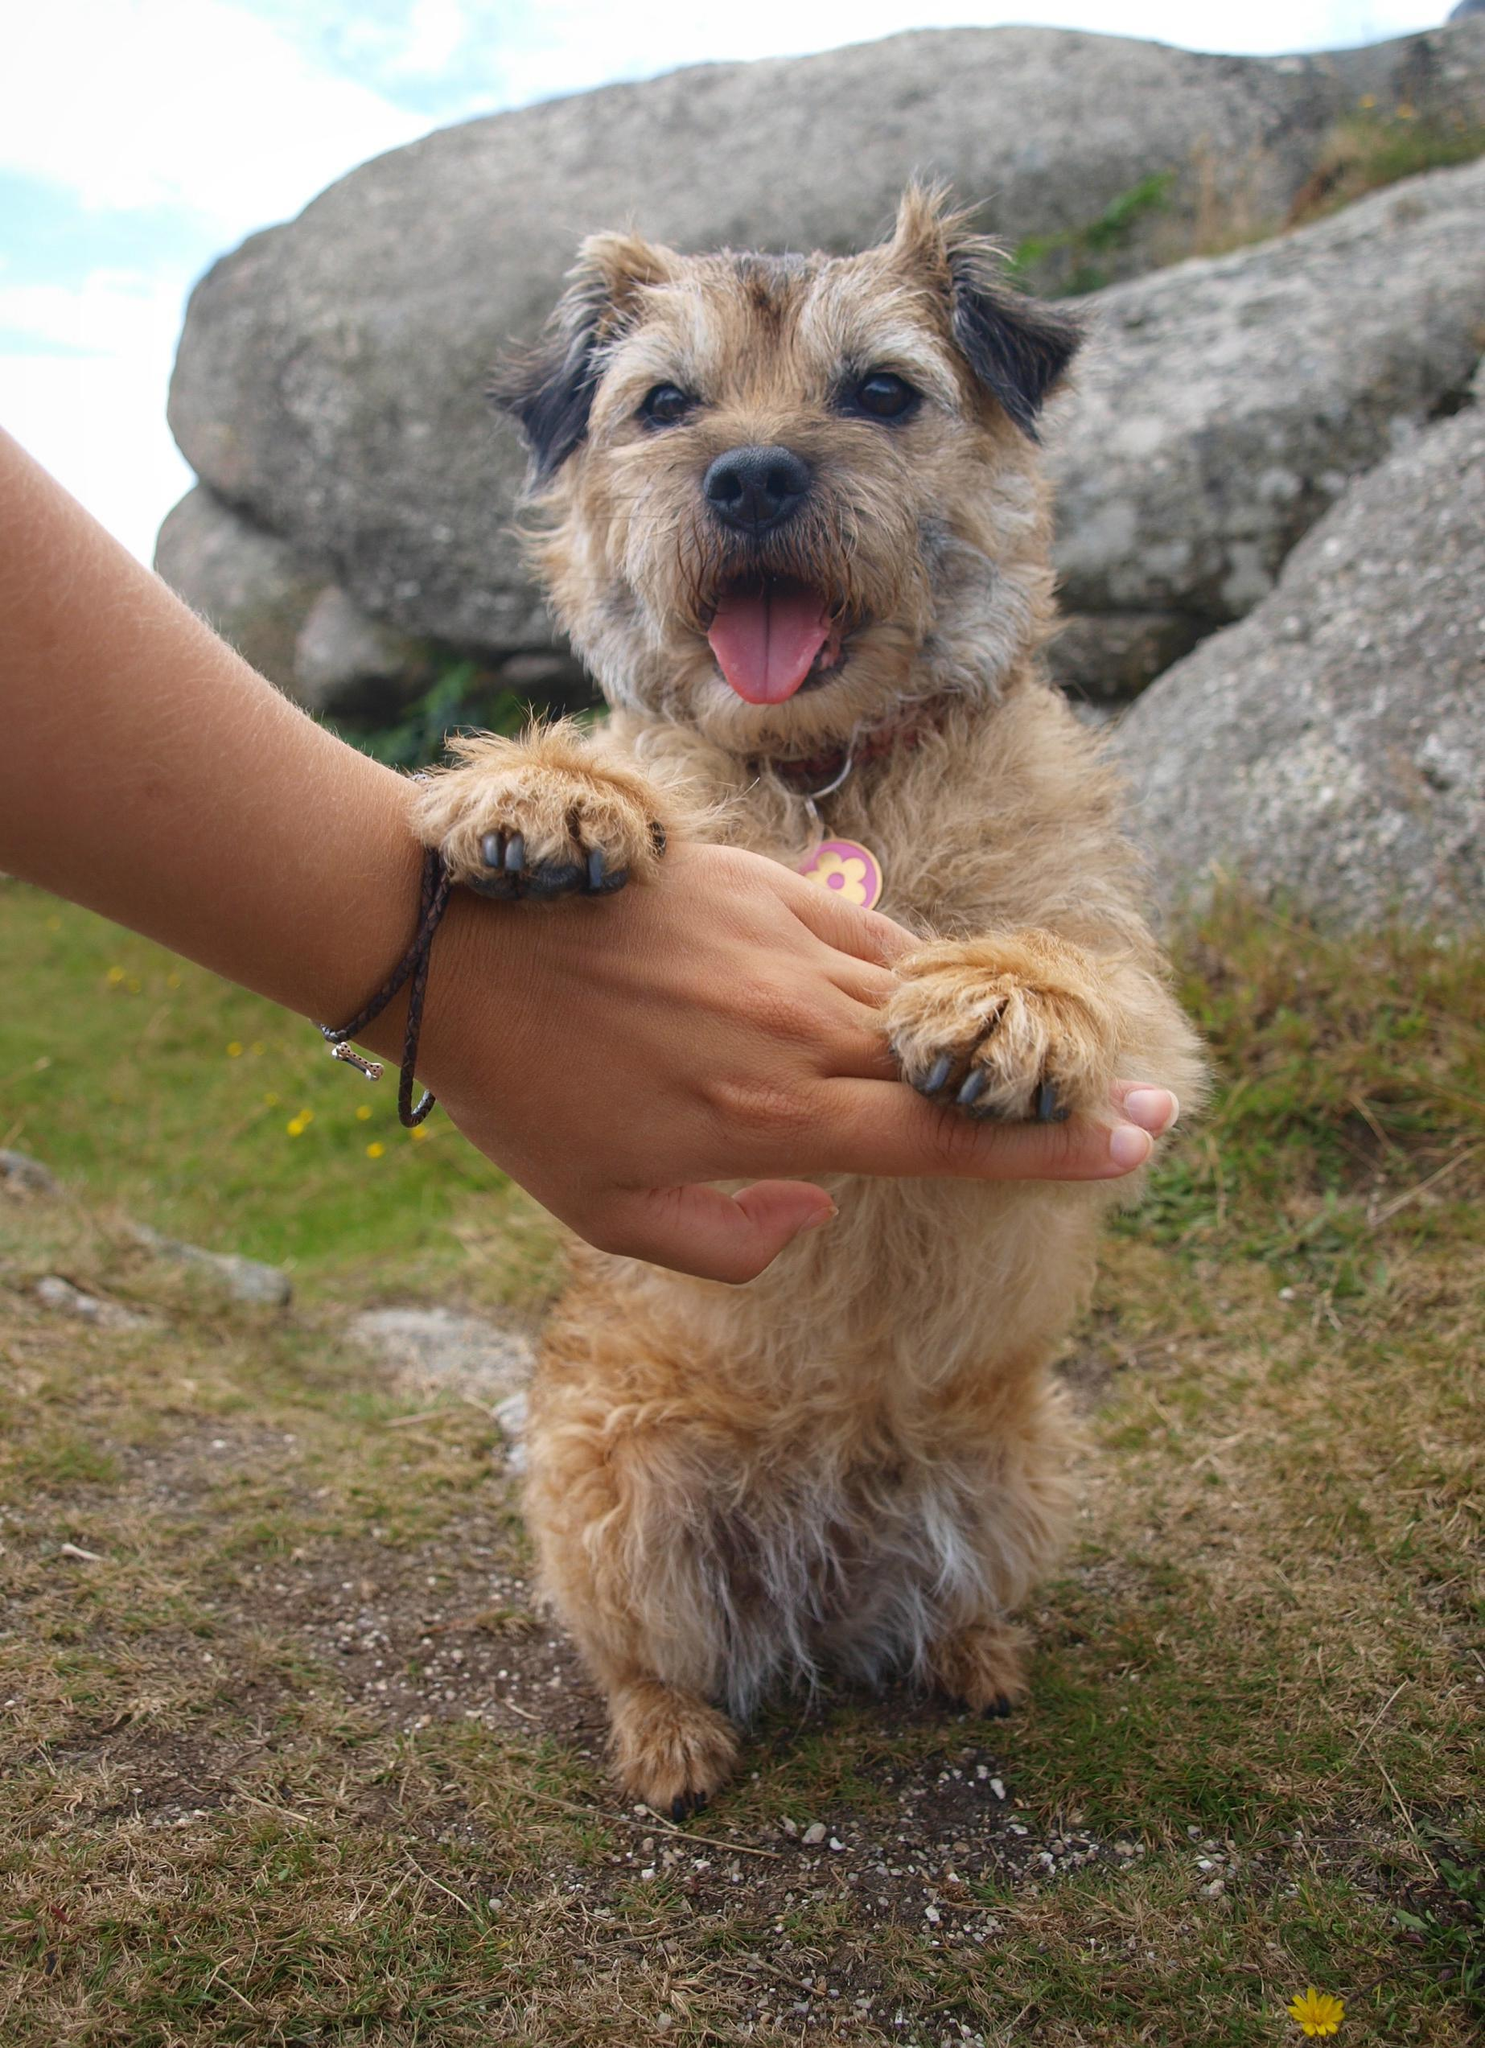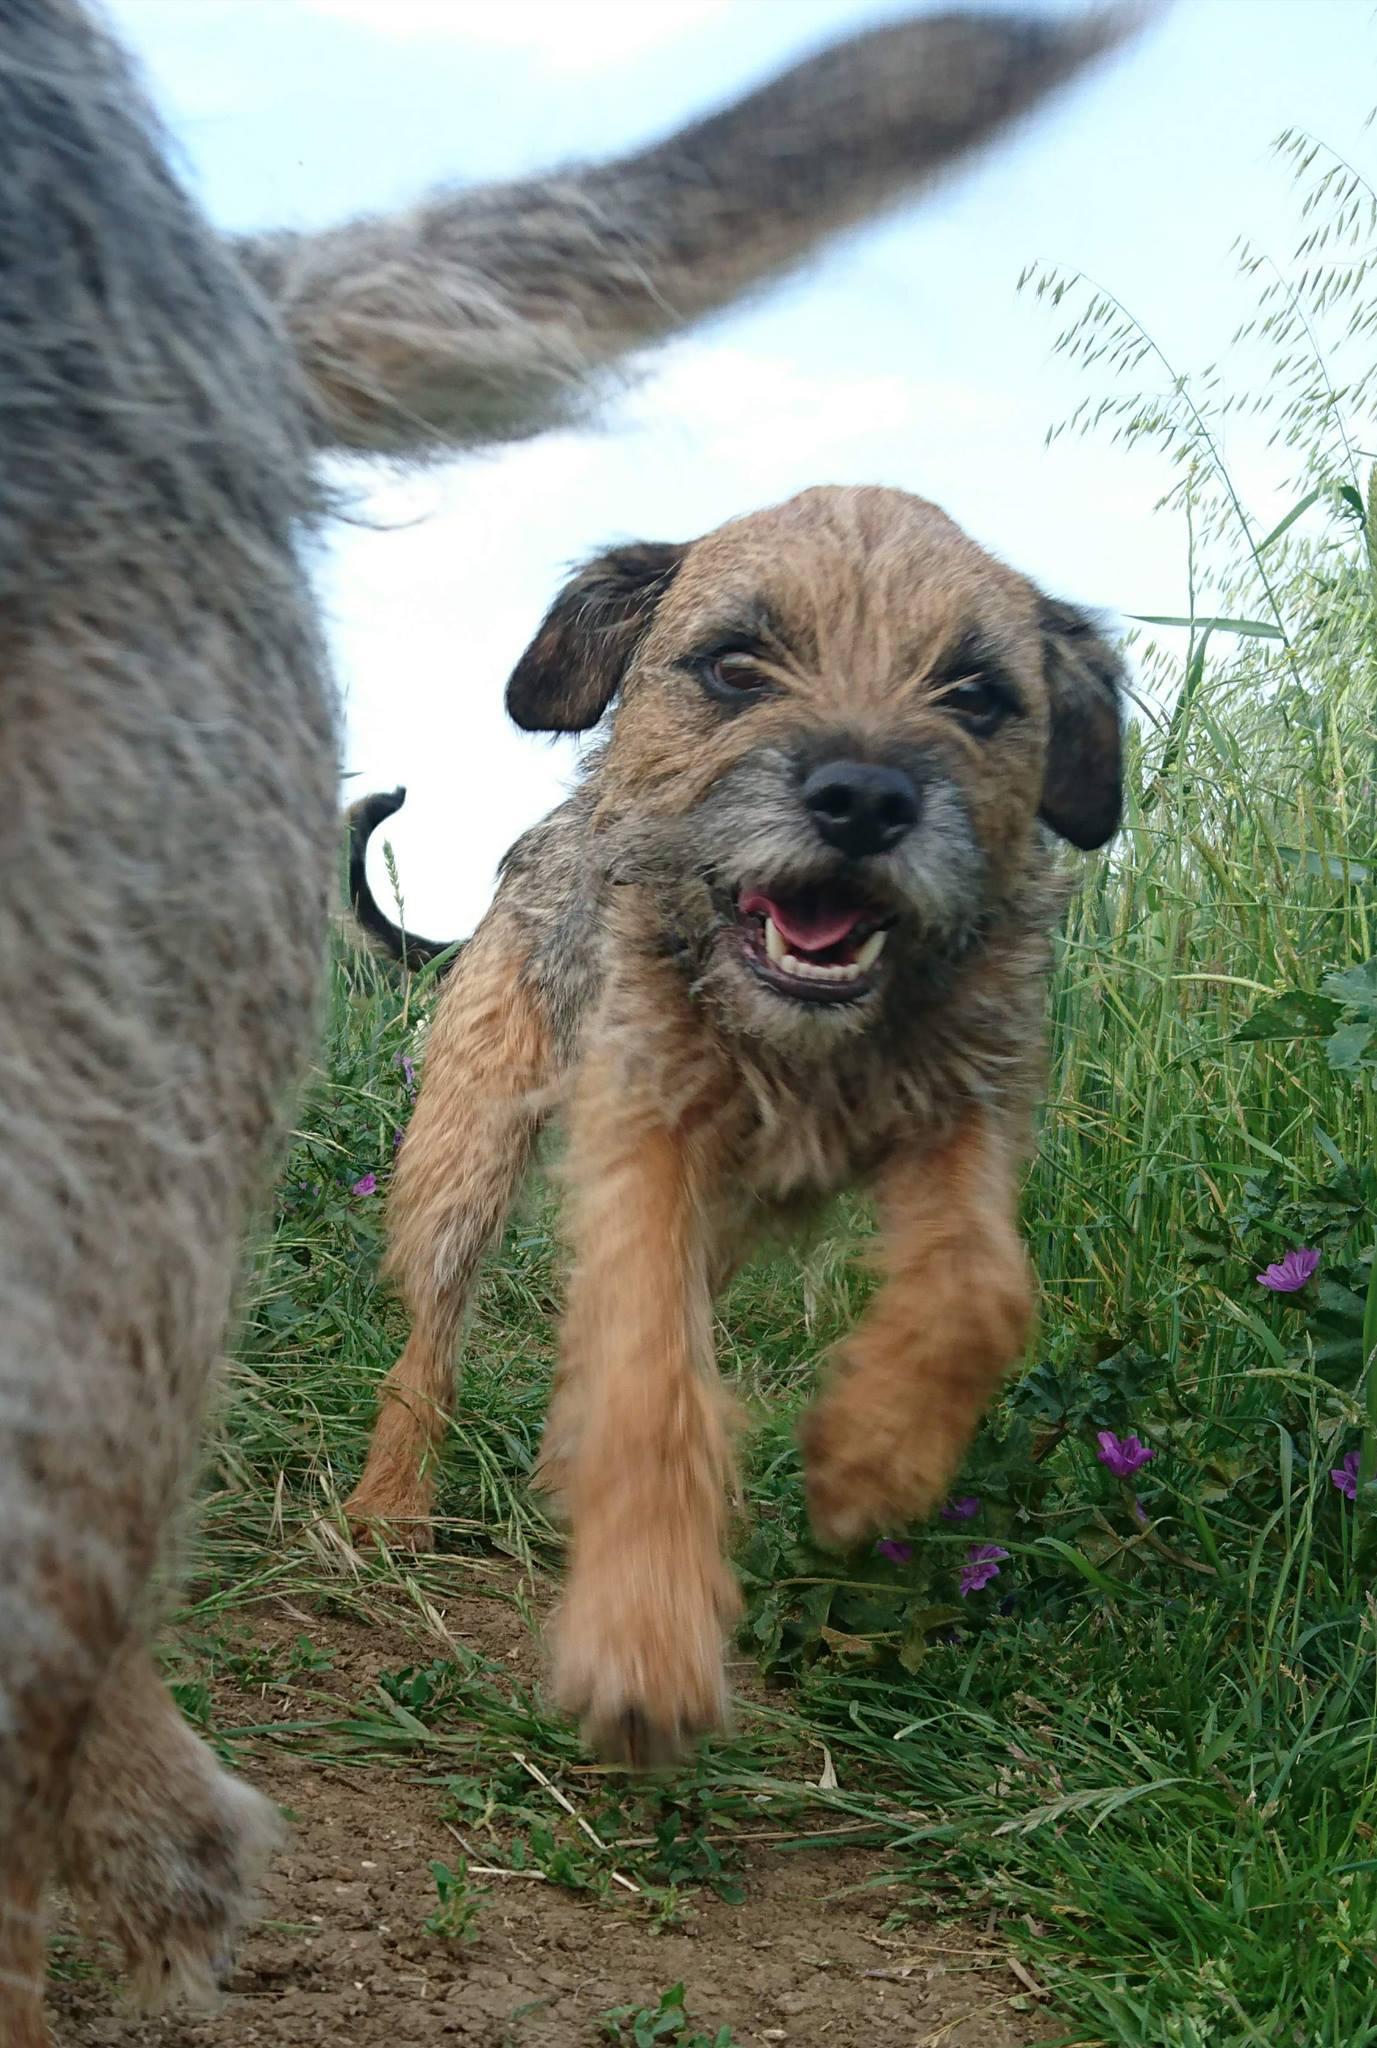The first image is the image on the left, the second image is the image on the right. Examine the images to the left and right. Is the description "The left image shows a dog sitting with all paws on the grass." accurate? Answer yes or no. No. The first image is the image on the left, the second image is the image on the right. For the images shown, is this caption "The left and right image contains the same number of dogs with one running on grass." true? Answer yes or no. Yes. 